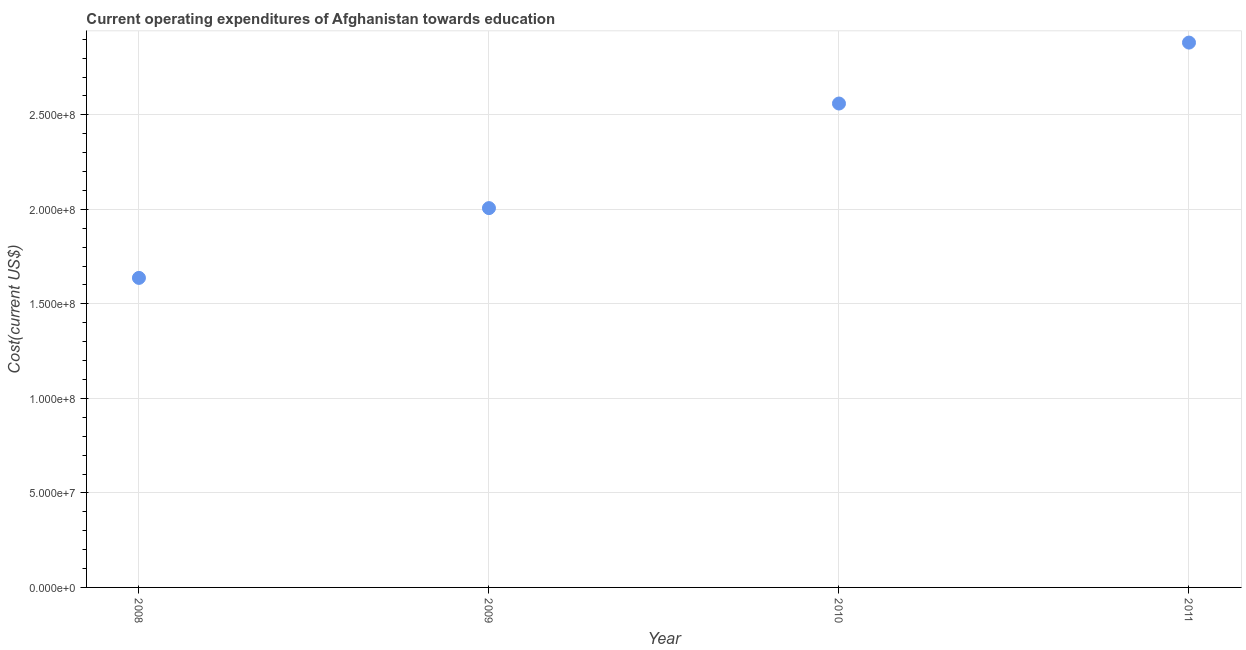What is the education expenditure in 2008?
Make the answer very short. 1.64e+08. Across all years, what is the maximum education expenditure?
Provide a succinct answer. 2.88e+08. Across all years, what is the minimum education expenditure?
Offer a terse response. 1.64e+08. In which year was the education expenditure minimum?
Your answer should be very brief. 2008. What is the sum of the education expenditure?
Your answer should be very brief. 9.09e+08. What is the difference between the education expenditure in 2009 and 2010?
Your answer should be very brief. -5.53e+07. What is the average education expenditure per year?
Give a very brief answer. 2.27e+08. What is the median education expenditure?
Keep it short and to the point. 2.28e+08. In how many years, is the education expenditure greater than 30000000 US$?
Your answer should be compact. 4. What is the ratio of the education expenditure in 2008 to that in 2010?
Offer a terse response. 0.64. Is the difference between the education expenditure in 2008 and 2011 greater than the difference between any two years?
Offer a very short reply. Yes. What is the difference between the highest and the second highest education expenditure?
Keep it short and to the point. 3.22e+07. Is the sum of the education expenditure in 2009 and 2011 greater than the maximum education expenditure across all years?
Make the answer very short. Yes. What is the difference between the highest and the lowest education expenditure?
Provide a short and direct response. 1.24e+08. In how many years, is the education expenditure greater than the average education expenditure taken over all years?
Keep it short and to the point. 2. Does the education expenditure monotonically increase over the years?
Offer a very short reply. Yes. How many dotlines are there?
Provide a succinct answer. 1. How many years are there in the graph?
Offer a terse response. 4. What is the difference between two consecutive major ticks on the Y-axis?
Offer a very short reply. 5.00e+07. What is the title of the graph?
Ensure brevity in your answer.  Current operating expenditures of Afghanistan towards education. What is the label or title of the X-axis?
Your response must be concise. Year. What is the label or title of the Y-axis?
Provide a short and direct response. Cost(current US$). What is the Cost(current US$) in 2008?
Keep it short and to the point. 1.64e+08. What is the Cost(current US$) in 2009?
Provide a succinct answer. 2.01e+08. What is the Cost(current US$) in 2010?
Offer a very short reply. 2.56e+08. What is the Cost(current US$) in 2011?
Provide a short and direct response. 2.88e+08. What is the difference between the Cost(current US$) in 2008 and 2009?
Provide a short and direct response. -3.69e+07. What is the difference between the Cost(current US$) in 2008 and 2010?
Offer a terse response. -9.22e+07. What is the difference between the Cost(current US$) in 2008 and 2011?
Provide a short and direct response. -1.24e+08. What is the difference between the Cost(current US$) in 2009 and 2010?
Provide a short and direct response. -5.53e+07. What is the difference between the Cost(current US$) in 2009 and 2011?
Give a very brief answer. -8.76e+07. What is the difference between the Cost(current US$) in 2010 and 2011?
Ensure brevity in your answer.  -3.22e+07. What is the ratio of the Cost(current US$) in 2008 to that in 2009?
Keep it short and to the point. 0.82. What is the ratio of the Cost(current US$) in 2008 to that in 2010?
Ensure brevity in your answer.  0.64. What is the ratio of the Cost(current US$) in 2008 to that in 2011?
Ensure brevity in your answer.  0.57. What is the ratio of the Cost(current US$) in 2009 to that in 2010?
Your answer should be compact. 0.78. What is the ratio of the Cost(current US$) in 2009 to that in 2011?
Ensure brevity in your answer.  0.7. What is the ratio of the Cost(current US$) in 2010 to that in 2011?
Your response must be concise. 0.89. 